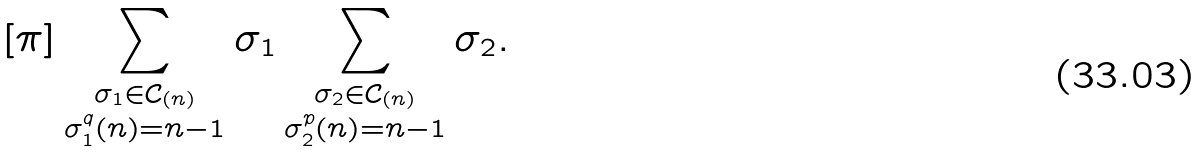<formula> <loc_0><loc_0><loc_500><loc_500>[ \pi ] \sum _ { \substack { \sigma _ { 1 } \in \mathcal { C } _ { ( n ) } \\ \sigma _ { 1 } ^ { q } ( n ) = n - 1 } } \sigma _ { 1 } \sum _ { \substack { \sigma _ { 2 } \in \mathcal { C } _ { ( n ) } \\ \sigma _ { 2 } ^ { p } ( n ) = n - 1 } } \sigma _ { 2 } .</formula> 